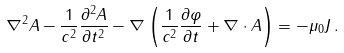<formula> <loc_0><loc_0><loc_500><loc_500>\nabla ^ { 2 } A - { \frac { 1 } { c ^ { 2 } } } { \frac { \partial ^ { 2 } A } { \partial t ^ { 2 } } } - \nabla \left ( { \frac { 1 } { c ^ { 2 } } } { \frac { \partial \varphi } { \partial t } } + \nabla \cdot A \right ) = - \mu _ { 0 } J \, .</formula> 